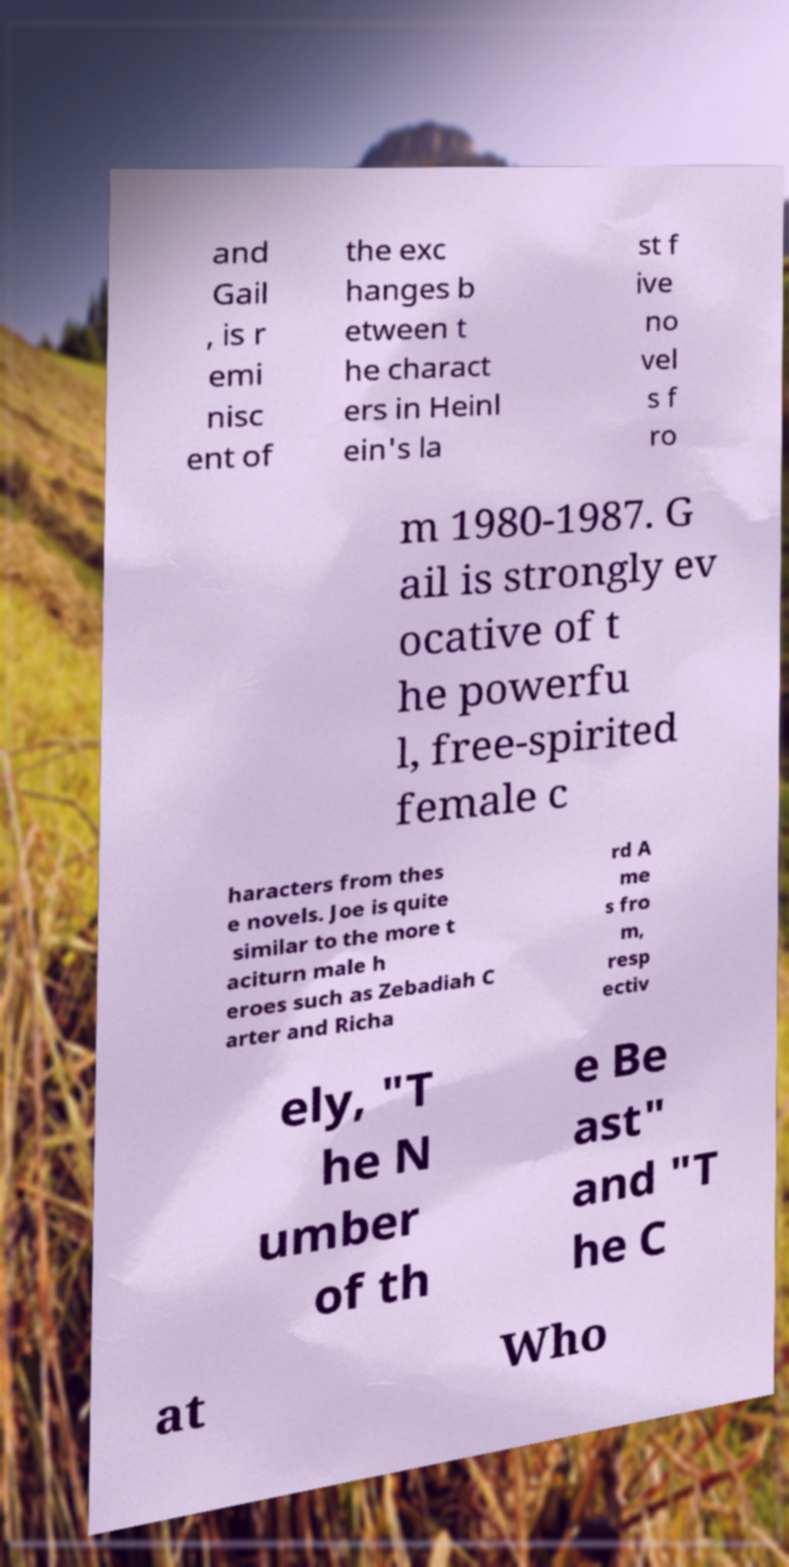Can you accurately transcribe the text from the provided image for me? and Gail , is r emi nisc ent of the exc hanges b etween t he charact ers in Heinl ein's la st f ive no vel s f ro m 1980-1987. G ail is strongly ev ocative of t he powerfu l, free-spirited female c haracters from thes e novels. Joe is quite similar to the more t aciturn male h eroes such as Zebadiah C arter and Richa rd A me s fro m, resp ectiv ely, "T he N umber of th e Be ast" and "T he C at Who 